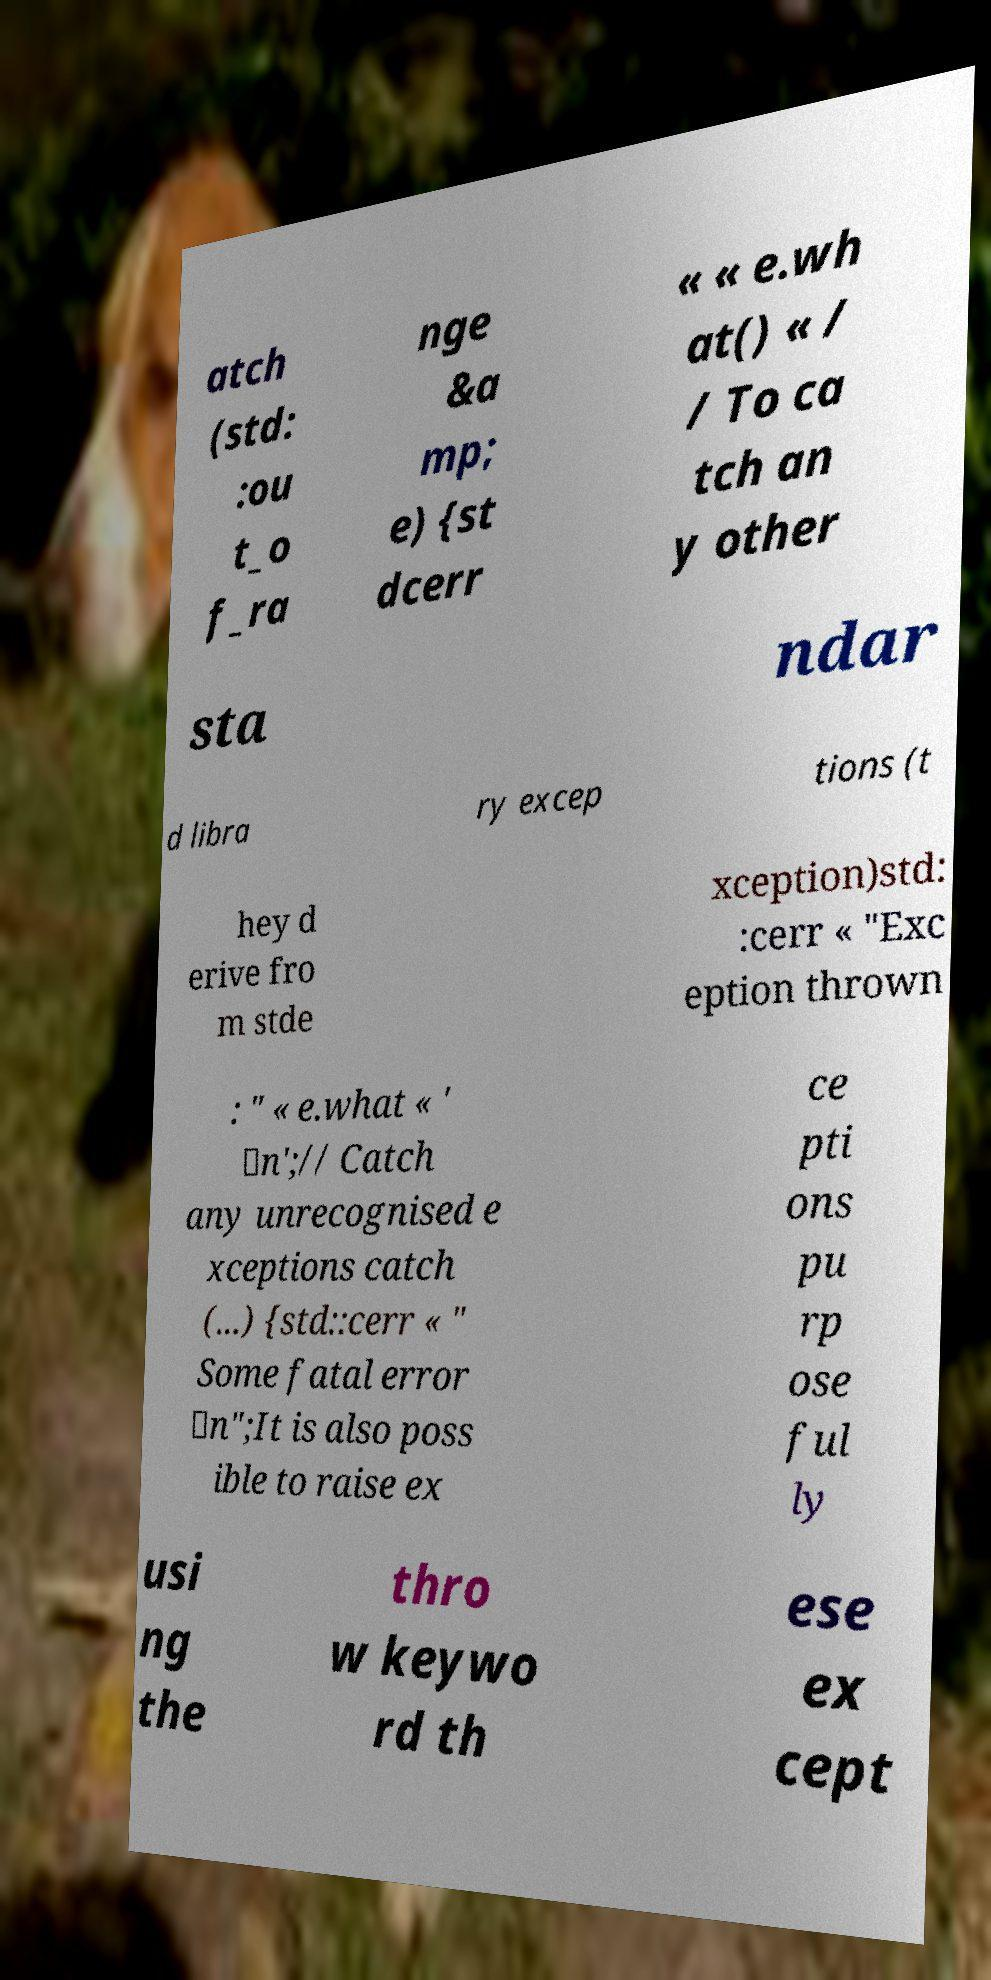I need the written content from this picture converted into text. Can you do that? atch (std: :ou t_o f_ra nge &a mp; e) {st dcerr « « e.wh at() « / / To ca tch an y other sta ndar d libra ry excep tions (t hey d erive fro m stde xception)std: :cerr « "Exc eption thrown : " « e.what « ' \n';// Catch any unrecognised e xceptions catch (...) {std::cerr « " Some fatal error \n";It is also poss ible to raise ex ce pti ons pu rp ose ful ly usi ng the thro w keywo rd th ese ex cept 